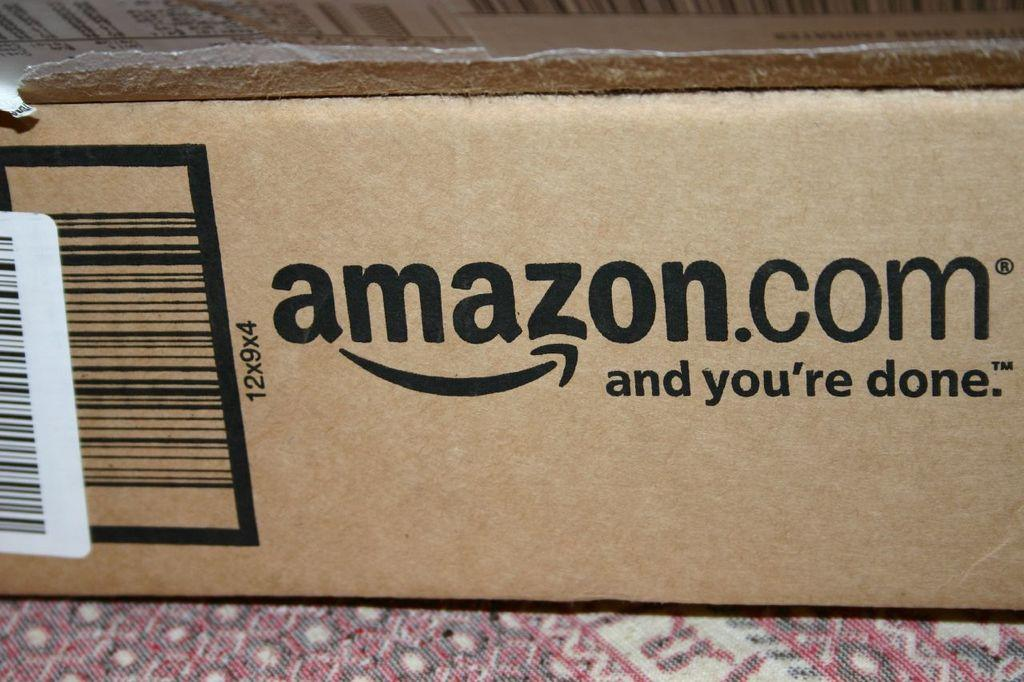<image>
Create a compact narrative representing the image presented. A brown box that says amazon.com and you're done on the outside. 